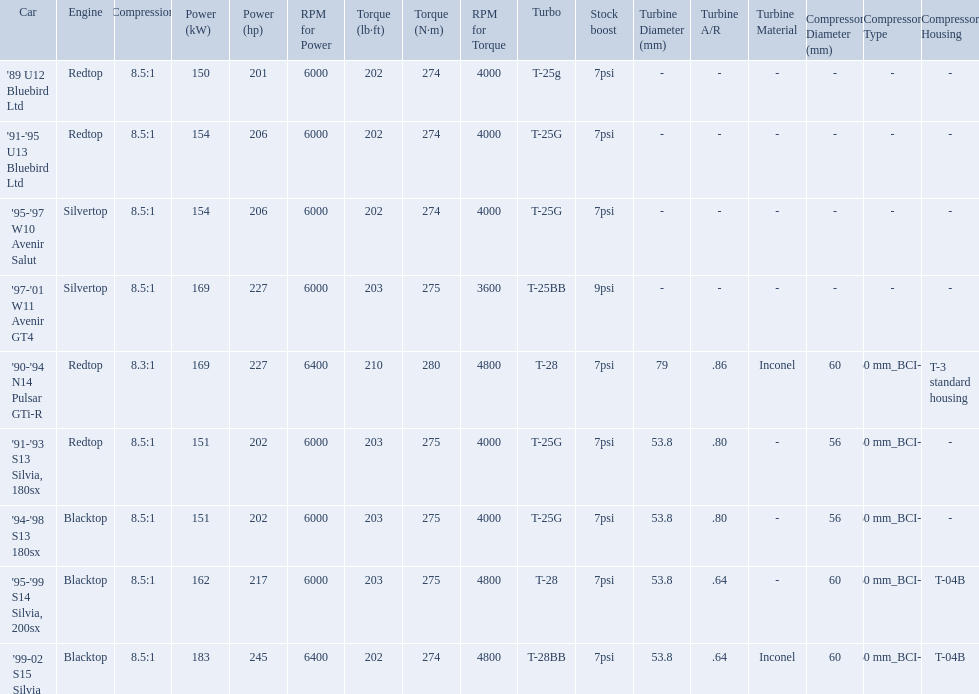Which cars featured blacktop engines? '94-'98 S13 180sx, '95-'99 S14 Silvia, 200sx, '99-02 S15 Silvia. Which of these had t-04b compressor housings? '95-'99 S14 Silvia, 200sx, '99-02 S15 Silvia. Which one of these has the highest horsepower? '99-02 S15 Silvia. Write the full table. {'header': ['Car', 'Engine', 'Compression', 'Power (kW)', 'Power (hp)', 'RPM for Power', 'Torque (lb·ft)', 'Torque (N·m)', 'RPM for Torque', 'Turbo', 'Stock boost', 'Turbine Diameter (mm)', 'Turbine A/R', 'Turbine Material', 'Compressor Diameter (mm)', 'Compressor Type', 'Compressor Housing'], 'rows': [["'89 U12 Bluebird Ltd", 'Redtop', '8.5:1', '150', '201', '6000', '202', '274', '4000', 'T-25g', '7psi', '-', '-', '-', '-', '-', '-'], ["'91-'95 U13 Bluebird Ltd", 'Redtop', '8.5:1', '154', '206', '6000', '202', '274', '4000', 'T-25G', '7psi', '-', '-', '-', '-', '-', '-'], ["'95-'97 W10 Avenir Salut", 'Silvertop', '8.5:1', '154', '206', '6000', '202', '274', '4000', 'T-25G', '7psi', '-', '-', '-', '-', '-', '-'], ["'97-'01 W11 Avenir GT4", 'Silvertop', '8.5:1', '169', '227', '6000', '203', '275', '3600', 'T-25BB', '9psi', '-', '-', '-', '-', '-', '-'], ["'90-'94 N14 Pulsar GTi-R", 'Redtop', '8.3:1', '169', '227', '6400', '210', '280', '4800', 'T-28', '7psi', '79', '.86', 'Inconel', '60', '60\xa0mm_BCI-1', 'T-3 standard housing'], ["'91-'93 S13 Silvia, 180sx", 'Redtop', '8.5:1', '151', '202', '6000', '203', '275', '4000', 'T-25G', '7psi', '53.8', '.80', '-', '56', '60\xa0mm_BCI-1', '-'], ["'94-'98 S13 180sx", 'Blacktop', '8.5:1', '151', '202', '6000', '203', '275', '4000', 'T-25G', '7psi', '53.8', '.80', '-', '56', '60\xa0mm_BCI-1', '-'], ["'95-'99 S14 Silvia, 200sx", 'Blacktop', '8.5:1', '162', '217', '6000', '203', '275', '4800', 'T-28', '7psi', '53.8', '.64', '-', '60', '60\xa0mm_BCI-1', 'T-04B'], ["'99-02 S15 Silvia", 'Blacktop', '8.5:1', '183', '245', '6400', '202', '274', '4800', 'T-28BB', '7psi', '53.8', '.64', 'Inconel', '60', '60\xa0mm_BCI-1', 'T-04B']]} What are the listed hp of the cars? 150 kW (201 hp) @ 6000 rpm, 154 kW (206 hp) @ 6000 rpm, 154 kW (206 hp) @ 6000 rpm, 169 kW (227 hp) @ 6000 rpm, 169 kW (227 hp) @ 6400 rpm (Euro: 164 kW (220 hp) @ 6400 rpm), 151 kW (202 hp) @ 6000 rpm, 151 kW (202 hp) @ 6000 rpm, 162 kW (217 hp) @ 6000 rpm, 183 kW (245 hp) @ 6400 rpm. Which is the only car with over 230 hp? '99-02 S15 Silvia. What are the psi's? 7psi, 7psi, 7psi, 9psi, 7psi, 7psi, 7psi, 7psi, 7psi. What are the number(s) greater than 7? 9psi. Which car has that number? '97-'01 W11 Avenir GT4. 